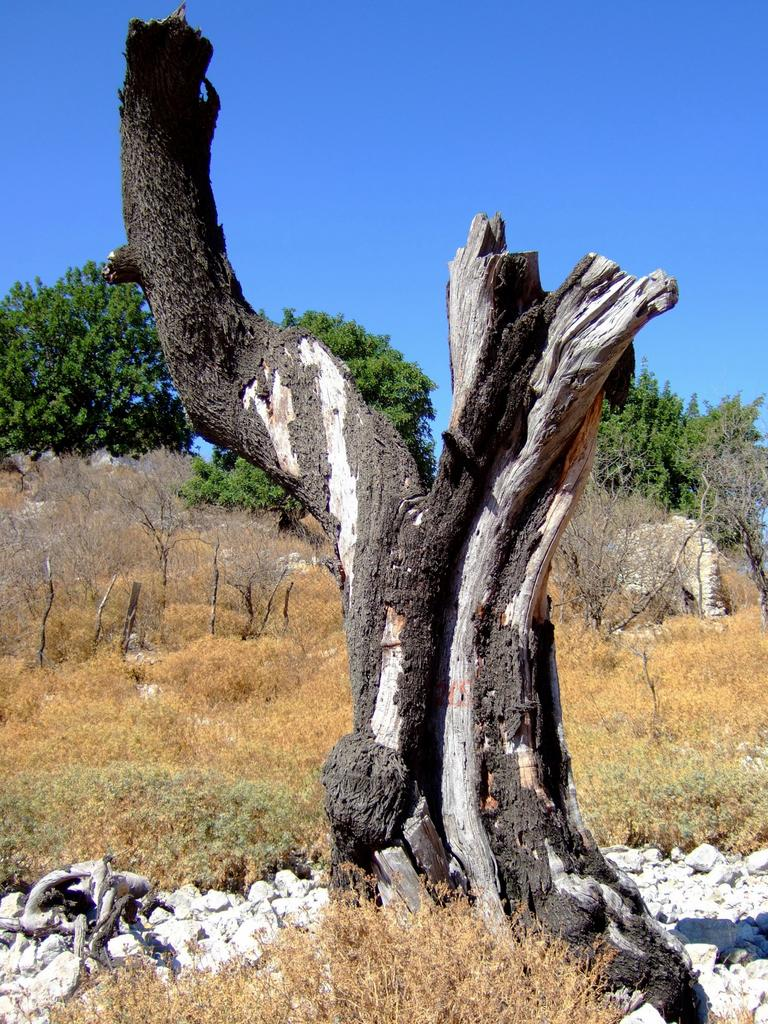What type of vegetation can be seen in the image? There are trees and grass in the image. What other objects can be found in the image? There are stones in the image. Can you describe the tree in the center of the image? The bark of a tree is visible in the center of the image. What is visible in the background of the image? The sky is visible in the background of the image. What is the reaction of the ant to the cow in the image? There is no cow present in the image, so there is no reaction of an ant to observe. 